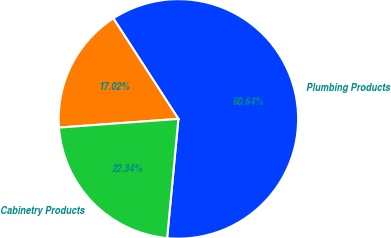Convert chart. <chart><loc_0><loc_0><loc_500><loc_500><pie_chart><fcel>Plumbing Products<fcel>Unnamed: 1<fcel>Cabinetry Products<nl><fcel>60.64%<fcel>17.02%<fcel>22.34%<nl></chart> 